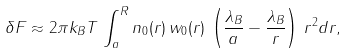<formula> <loc_0><loc_0><loc_500><loc_500>\delta F \approx 2 \pi k _ { B } T \, \int _ { a } ^ { R } n _ { 0 } ( r ) \, w _ { 0 } ( r ) \, \left ( \frac { \lambda _ { B } } { a } - \frac { \lambda _ { B } } { r } \right ) \, r ^ { 2 } d r ,</formula> 